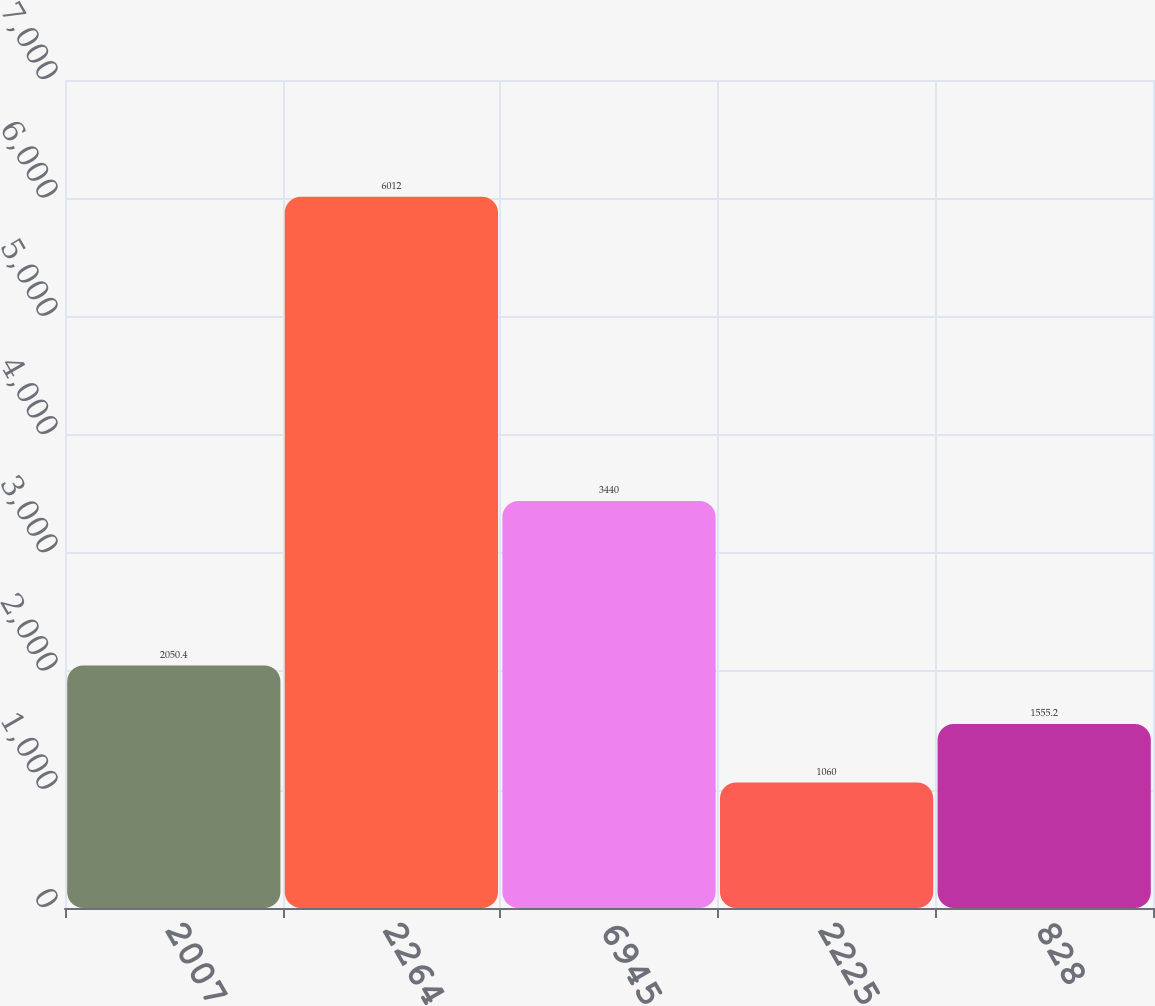<chart> <loc_0><loc_0><loc_500><loc_500><bar_chart><fcel>2007<fcel>2264<fcel>6945<fcel>2225<fcel>828<nl><fcel>2050.4<fcel>6012<fcel>3440<fcel>1060<fcel>1555.2<nl></chart> 